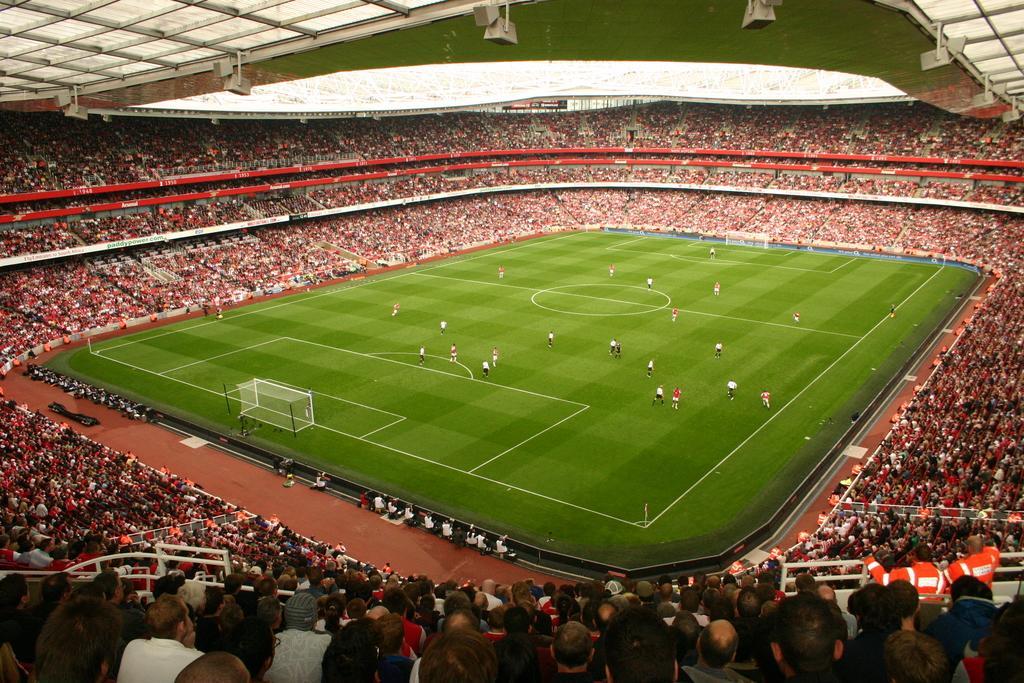Can you describe this image briefly? In the center of this picture we can see there are group of persons seems to be playing a game and we can see the nets, metal rods and the green grass. In the background we can see there are many number of people seems to be sitting on the chairs. At the top we can see the roof and some other objects. 